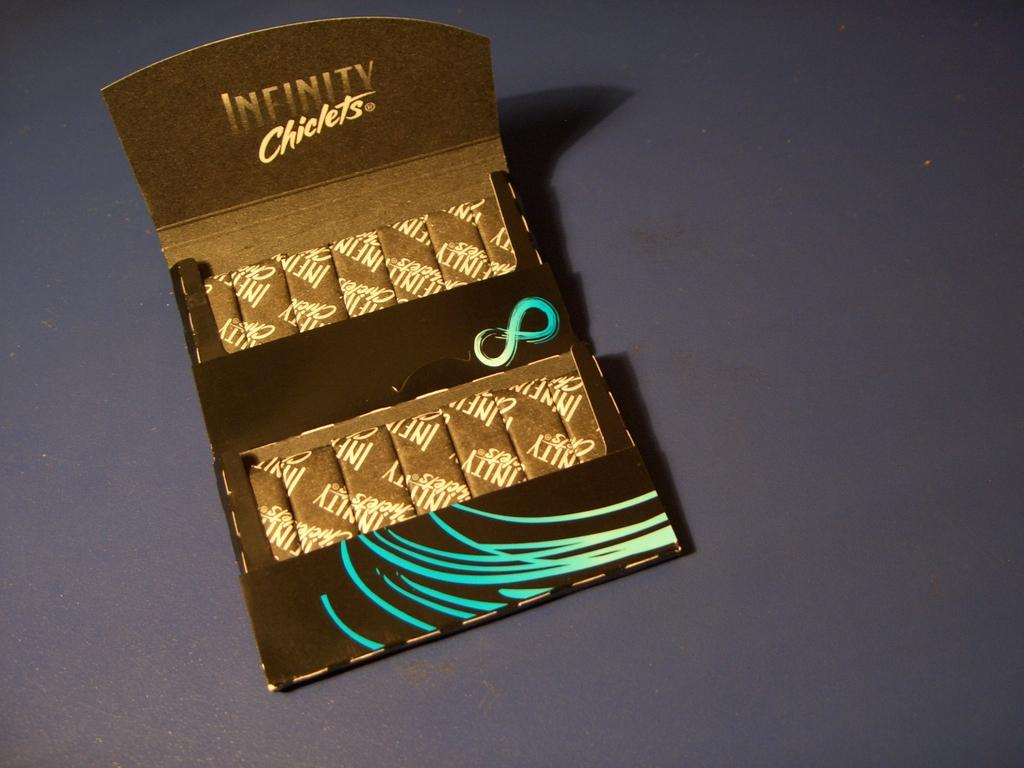<image>
Describe the image concisely. A brown box is shown with infinity chicklets written on the inside. 